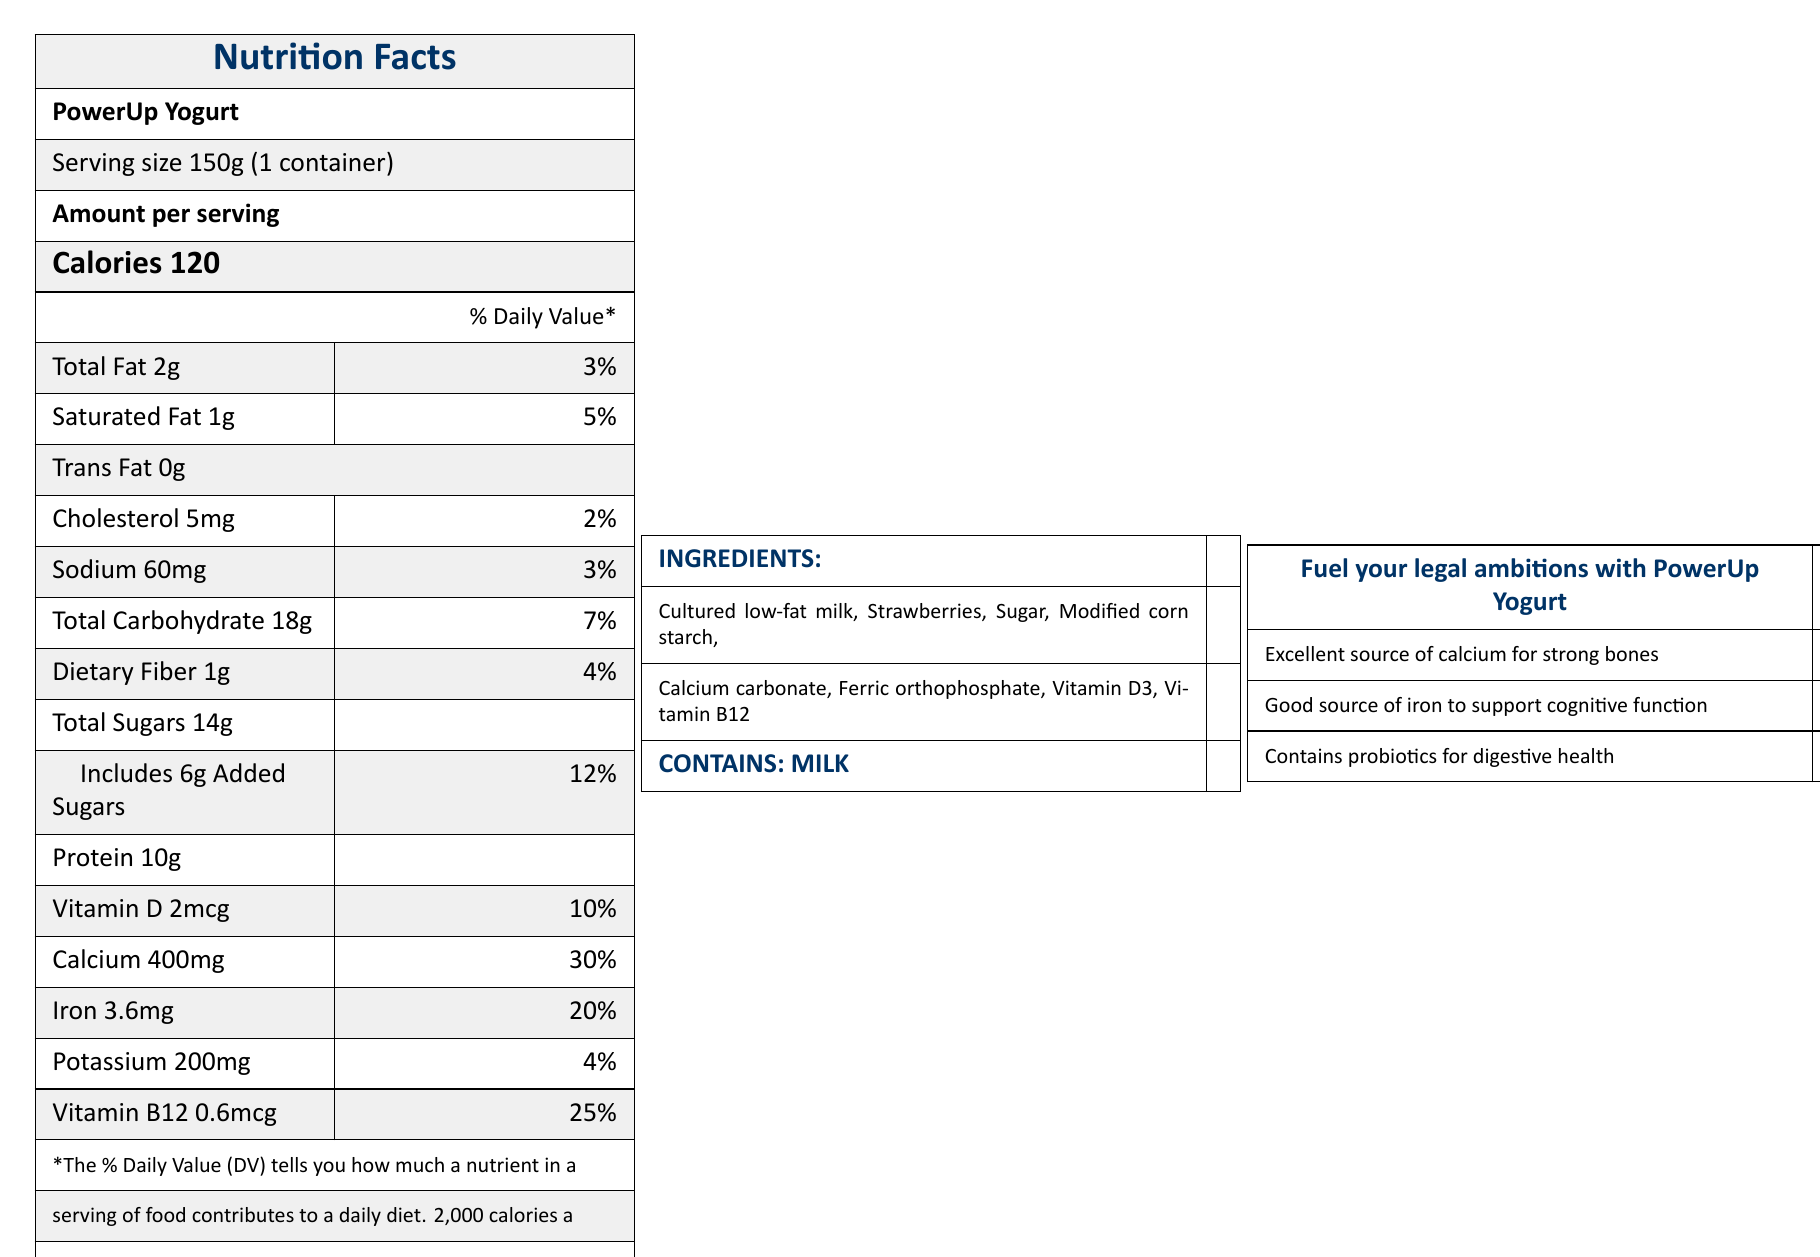what is the serving size of PowerUp Yogurt? The serving size is specified as "150g (1 container)" in the document.
Answer: 150g (1 container) how many calories are in one serving of PowerUp Yogurt? The document lists "Calories 120" under the amount per serving.
Answer: 120 what percentage of daily value is the calcium content in PowerUp Yogurt? The calcium content is indicated as "400mg" which is 30% of the daily value.
Answer: 30% how much protein does PowerUp Yogurt contain per serving? The protein content per serving is listed as "Protein 10g" in the document.
Answer: 10g what allergens are present in PowerUp Yogurt based on the label? The allergens section states "Contains milk".
Answer: Milk how much added sugar is in PowerUp Yogurt? The label lists "Includes 6g Added Sugars" under the total sugars section.
Answer: 6g are there any probiotics mentioned in PowerUp Yogurt? The document mentions "Contains probiotics for digestive health" as part of the health claims.
Answer: Yes what are the primary target audiences for PowerUp Yogurt? The target audience is specified as "Busy female professionals and students in demanding careers".
Answer: Busy female professionals and students in demanding careers which vitamin contributes 25% of the daily value in PowerUp Yogurt? A. Vitamin D B. Calcium C. Iron D. Vitamin B12 The document lists "Vitamin B12 0.6mcg 25%" for daily value.
Answer: D how much iron does PowerUp Yogurt provide per serving?  A. 3.6mg B. 5mg C. 400mg D. 2mcg The document mentions "Iron 3.6mg 20%" under the amount per serving.
Answer: A does PowerUp Yogurt contain strawberries as an ingredient? Strawberries are listed as one of the ingredients in the document.
Answer: Yes is PowerUp Yogurt marketed for supporting bone health? The health claims include "Excellent source of calcium for strong bones".
Answer: Yes what is the main idea of the PowerUp Yogurt document? The document includes nutritional facts, ingredients, health claims and marketing targeted at busy female professionals and students, highlighting its benefits related to calcium, iron, probiotics, and convenient energy for demanding schedules.
Answer: The document provides detailed nutritional information, ingredients, allergen information, health claims, target audience, and benefits of PowerUp Yogurt, emphasizing its suitability for busy female professionals and students in demanding careers. how many grams of dietary fiber are in a serving of PowerUp Yogurt? The dietary fiber content per serving is listed as "Dietary Fiber 1g 4%" in the document.
Answer: 1g what are some benefits of consuming PowerUp Yogurt according to the document? The benefits include "Supports bone health with 30% daily value of calcium", "Helps prevent fatigue with 20% daily value of iron", "Provides quick, nutritious energy for long study sessions", and "Convenient on-the-go snack for courtroom breaks".
Answer: Supports bone health, helps prevent fatigue, provides quick nutritious energy, convenient snack for breaks who collaborated with nutritionists to develop PowerUp Yogurt? The brand story mentions that the yogurt was developed by nutritionists in collaboration with successful women in law, including notable figures like Henrietta Hill.
Answer: Successful women in law, including notable figures like Henrietta Hill what is the amount of potassium in PowerUp Yogurt? The document lists "Potassium 200mg 4%" under the amount per serving.
Answer: 200mg does PowerUp Yogurt contain any trans fat? The document states "Trans Fat 0g" under the amount per serving.
Answer: No how much vitamin D is present in PowerUp Yogurt? The document mentions "Vitamin D 2mcg 10%" under the amount per serving.
Answer: 2mcg how many servings are in one container of PowerUp Yogurt? The document specifies "servings per container: 1".
Answer: 1 what is the role of ferric orthophosphate in PowerUp Yogurt? The document lists ferric orthophosphate as an ingredient but does not specify its role.
Answer: Not enough information 